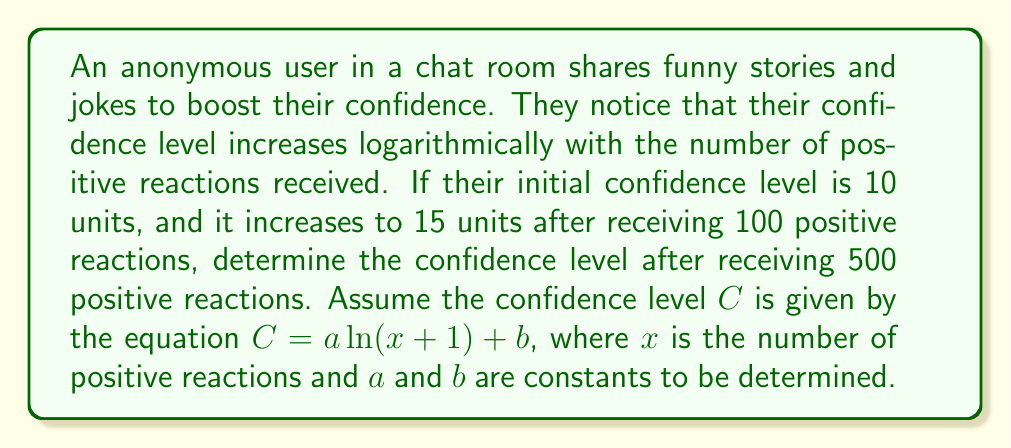Teach me how to tackle this problem. To solve this problem, we need to follow these steps:

1. Set up the equations using the given information:
   Initial condition: $10 = a \ln(1) + b$
   After 100 reactions: $15 = a \ln(101) + b$

2. Solve for $a$ and $b$:
   From the initial condition: $10 = b$ (since $\ln(1) = 0$)
   
   Substituting into the second equation:
   $15 = a \ln(101) + 10$
   $5 = a \ln(101)$
   $a = \frac{5}{\ln(101)} \approx 1.0861$

3. Now we have the complete equation:
   $C = 1.0861 \ln(x + 1) + 10$

4. To find the confidence level after 500 reactions, substitute $x = 500$:
   $C = 1.0861 \ln(501) + 10$

5. Calculate the final result:
   $C = 1.0861 \times 6.2166 + 10$
   $C = 6.7522 + 10$
   $C = 16.7522$

Therefore, the confidence level after receiving 500 positive reactions is approximately 16.75 units.
Answer: 16.75 units (rounded to two decimal places) 